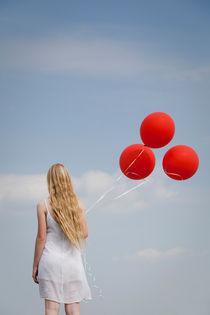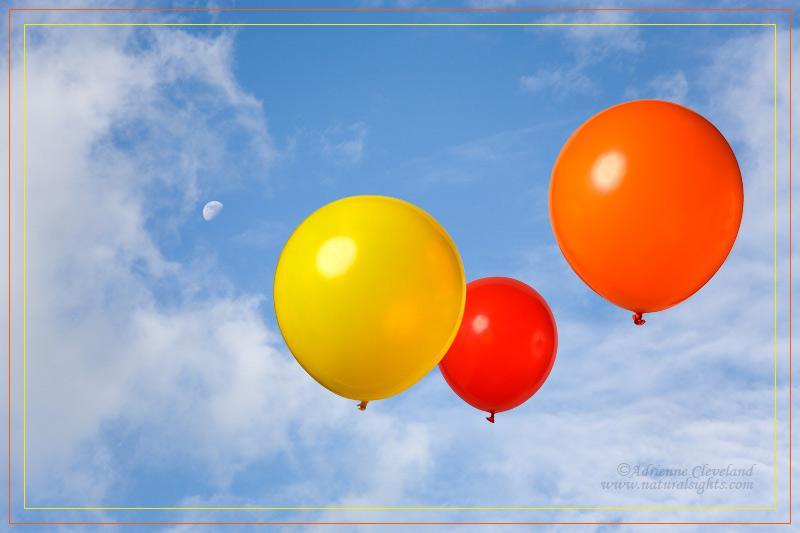The first image is the image on the left, the second image is the image on the right. Considering the images on both sides, is "There is at least two red balloons." valid? Answer yes or no. Yes. The first image is the image on the left, the second image is the image on the right. Given the left and right images, does the statement "Three balloons the same color and attached to strings are in one image, while a second image shows three balloons of different colors." hold true? Answer yes or no. Yes. 